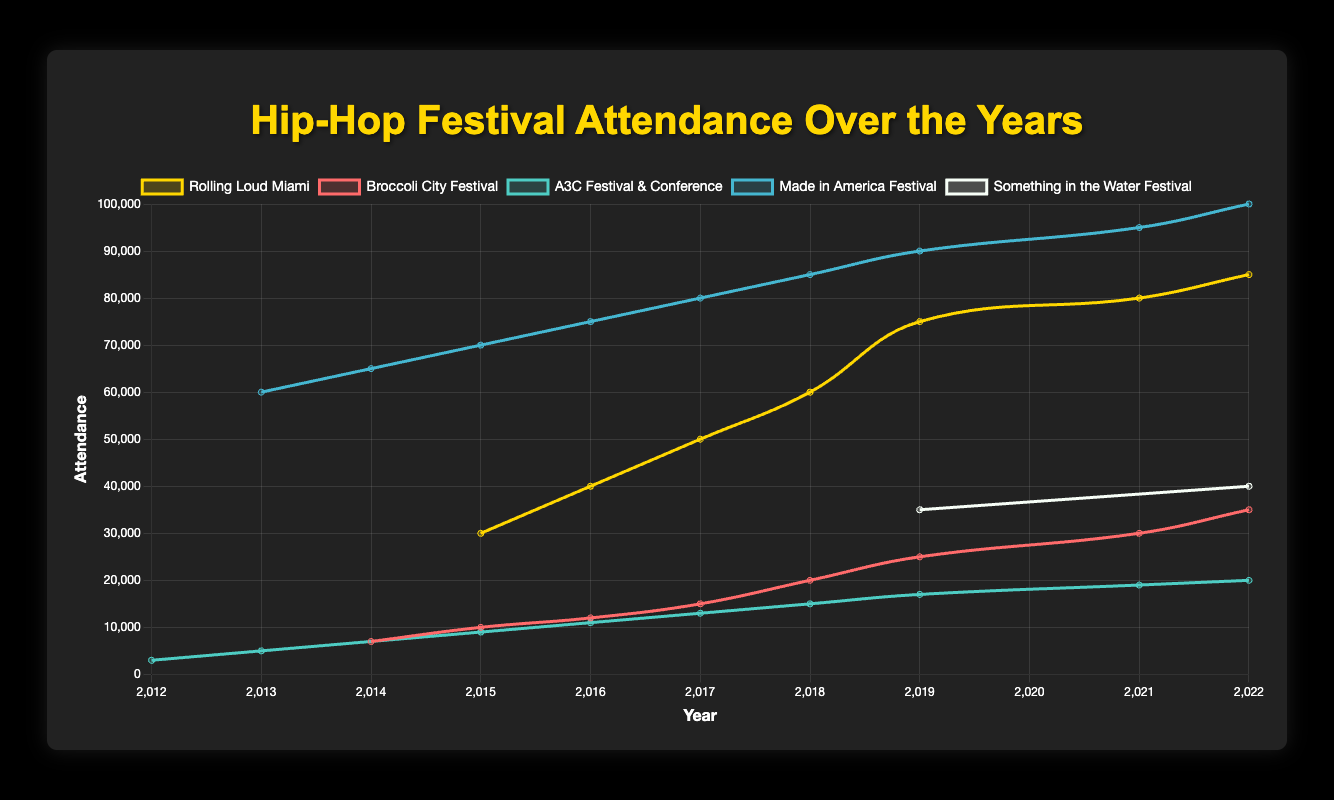What is the highest attendance for the Made in America Festival? In the visual, the highest attendance for Made in America Festival is represented by the tallest point in the 2022 year, reaching up to 100,000 attendees.
Answer: 100,000 Which festival had the largest attendance in 2022? Looking at the highest points on the 2022 line for all the festivals, the Made in America Festival had the largest attendance, represented by the highest point of 100,000 attendees.
Answer: Made in America Festival What was the difference in attendance between Rolling Loud Miami in 2015 and 2022? The data points show Rolling Loud Miami had 30,000 attendees in 2015 and 85,000 attendees in 2022. The difference is calculated as 85,000 - 30,000.
Answer: 55,000 Which festival experienced the largest increase in attendance from 2019 to 2022? Comparing the vertical distance between the data points in 2019 and 2022 for each festival, Rolling Loud Miami increased from 75,000 to 85,000, Broccoli City Festival from 25,000 to 35,000, A3C Festival & Conference from 17,000 to 20,000, and Something in the Water Festival from 35,000 to 40,000. Rolling Loud Miami had the largest increase of 10,000 attendees.
Answer: Rolling Loud Miami How many festivals had an attendance of at least 50,000 at any point in time? By visually examining the curves, the festivals with points reaching at least 50,000 attendees are Rolling Loud Miami, Made in America Festival, and Something in the Water Festival.
Answer: 3 What is the average attendance of the A3C Festival & Conference over the years shown? To find the average, add up all the attendance numbers for A3C Festival & Conference and divide by the number of years: (3000 + 5000 + 7000 + 9000 + 11000 + 13000 + 15000 + 17000 + 19000 + 20000) / 10 = 112,000 / 10.
Answer: 11,200 Which festival had the lowest starting attendance? By looking at the first data point for each festival, A3C Festival & Conference had the lowest starting attendance in 2012 with 3,000 attendees.
Answer: A3C Festival & Conference What is the combined attendance of Broccoli City Festival and A3C Festival & Conference in 2022? Sum the attendance numbers for Broccoli City Festival (35,000) and A3C Festival & Conference (20,000) for the year 2022: 35,000 + 20,000.
Answer: 55,000 Which festival attendance remained constant the longest without a break between years? Made in America Festival shows continuous data points from 2013 to 2022 without any missing years, representing constant and continuous attendance tracking.
Answer: Made in America Festival What's the difference in attendance between Rolling Loud Miami and Broccoli City Festival in 2022? Subtract the attendance of Broccoli City Festival (35,000) from Rolling Loud Miami's attendance (85,000) in 2022: 85,000 - 35,000.
Answer: 50,000 